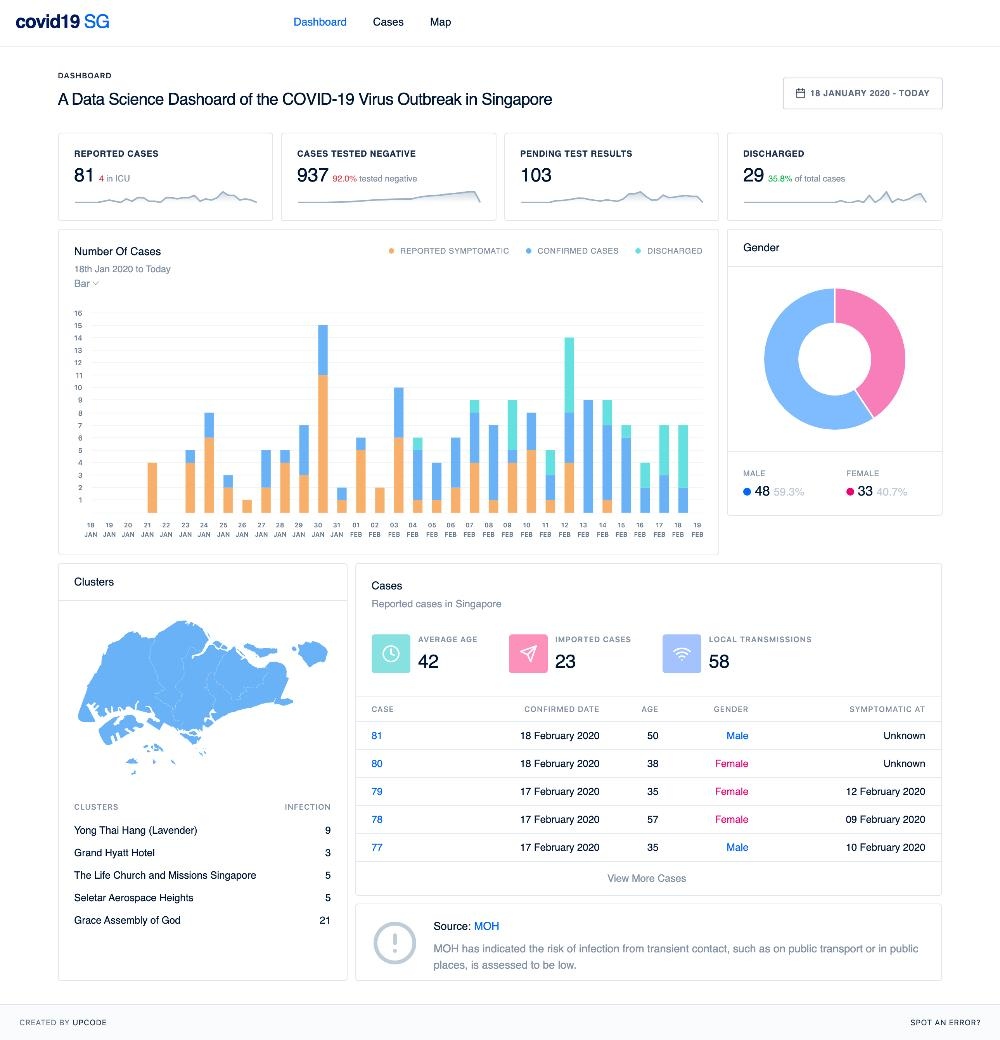Point out several critical features in this image. There are four individuals currently in the Intensive Care Unit (ICU). The average age is 42. The percentage of tested negative cases is 92.0%. There are 103 pending test results. There have been 23 imported cases. 